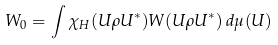Convert formula to latex. <formula><loc_0><loc_0><loc_500><loc_500>W _ { 0 } = \int \chi _ { H } ( U \rho U ^ { * } ) W ( U \rho U ^ { * } ) \, d \mu ( U )</formula> 